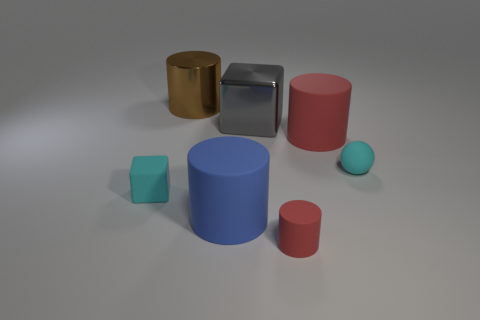Subtract all yellow cylinders. Subtract all blue blocks. How many cylinders are left? 4 Add 2 large green blocks. How many objects exist? 9 Subtract all spheres. How many objects are left? 6 Subtract 0 brown blocks. How many objects are left? 7 Subtract all yellow objects. Subtract all red matte cylinders. How many objects are left? 5 Add 4 tiny cyan objects. How many tiny cyan objects are left? 6 Add 5 large rubber things. How many large rubber things exist? 7 